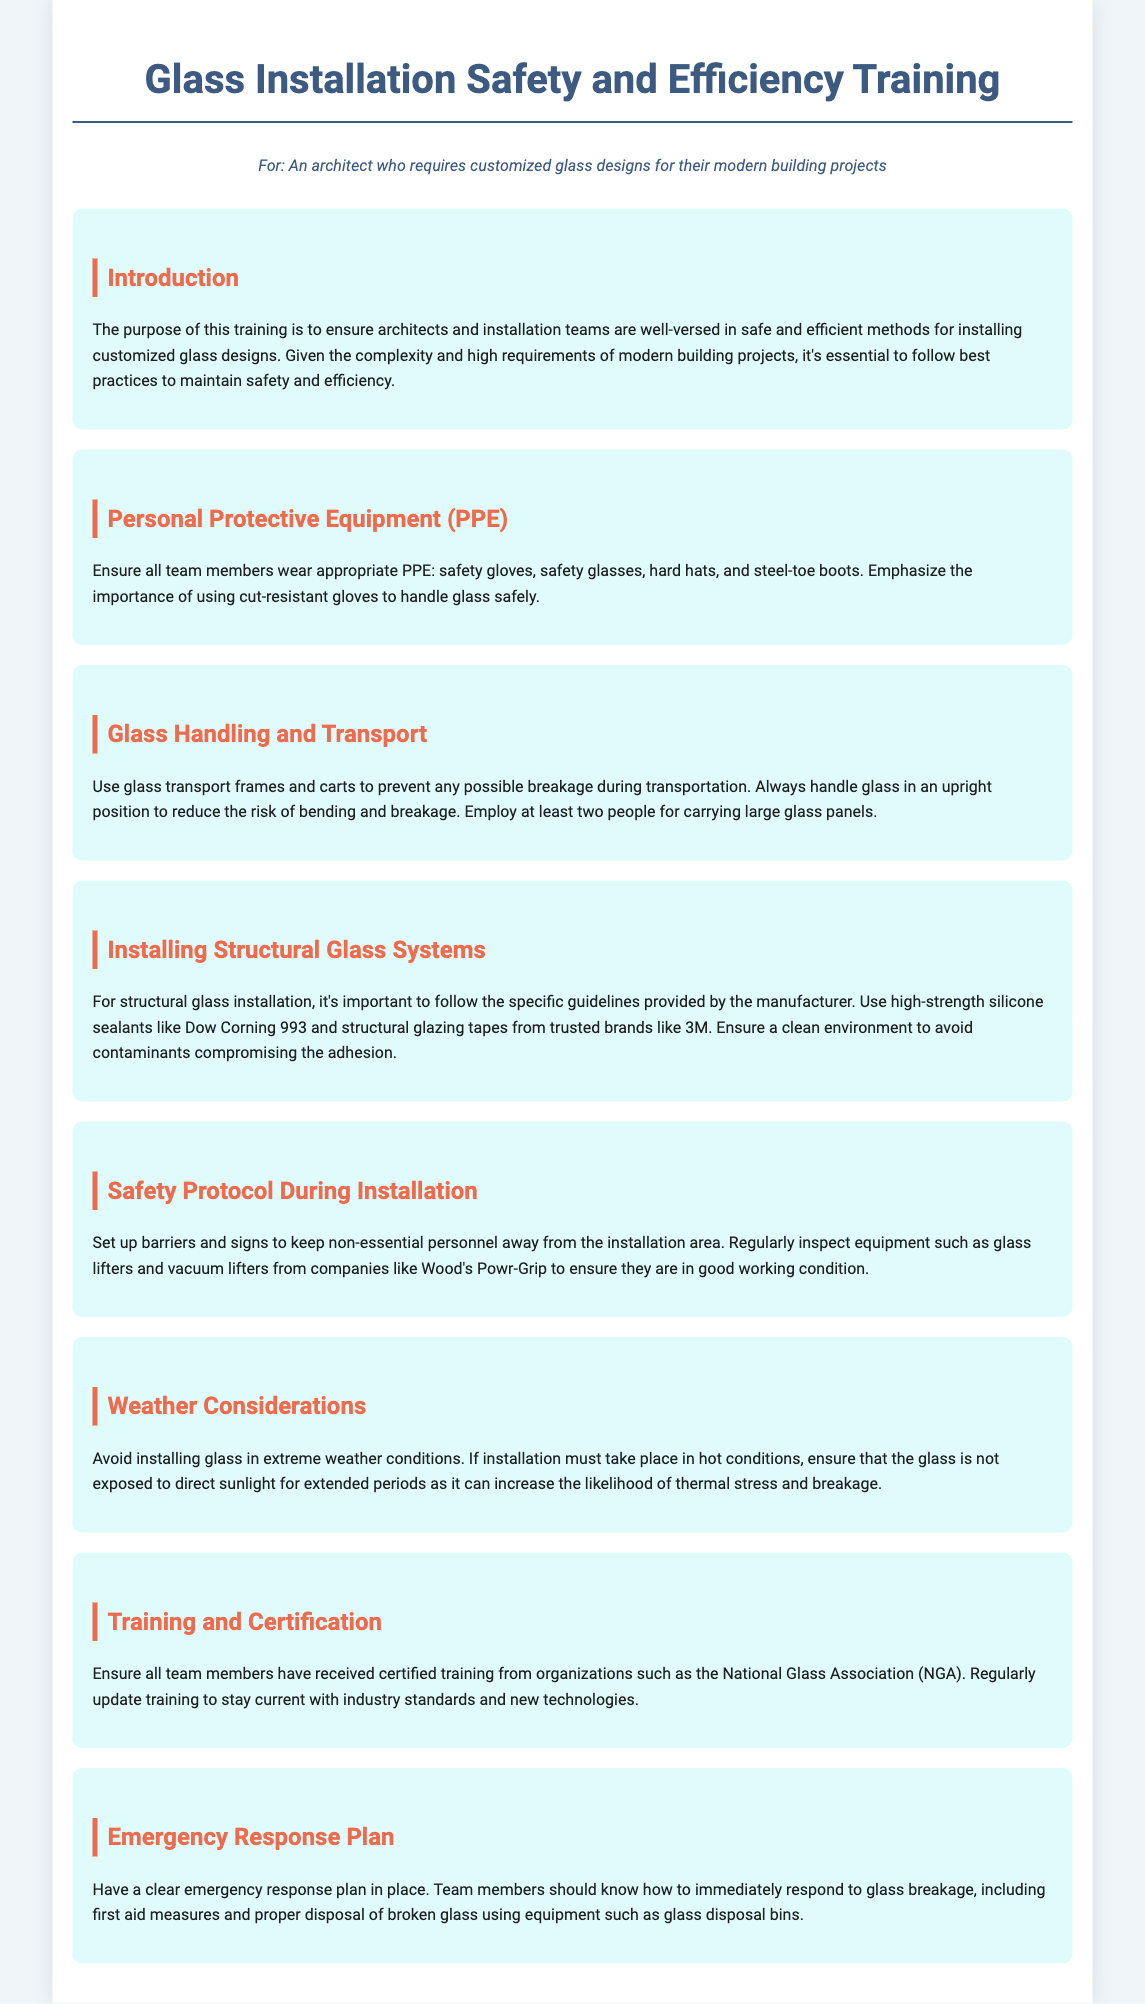What is the purpose of the training? The purpose of this training is to ensure architects and installation teams are well-versed in safe and efficient methods for installing customized glass designs.
Answer: To ensure safe and efficient methods for installing customized glass designs What type of sealants are recommended for structural glass installation? The document specifies using high-strength silicone sealants like Dow Corning 993 for structural glass installation.
Answer: Dow Corning 993 How should glass be transported to prevent breakage? The document advises using glass transport frames and carts to prevent any possible breakage during transportation.
Answer: Glass transport frames and carts How many people are recommended to carry large glass panels? The document suggests that at least two people are required for carrying large glass panels.
Answer: Two people What organization provides certified training for glass installation? The document mentions the National Glass Association (NGA) as the organization that provides certified training.
Answer: National Glass Association (NGA) Why should installation avoid extreme weather conditions? The document warns that extreme weather conditions can increase the likelihood of thermal stress and breakage during installation.
Answer: Thermal stress and breakage What should be used for proper disposal of broken glass? The document states that equipment such as glass disposal bins should be used for proper disposal of broken glass.
Answer: Glass disposal bins What is emphasized for the Personal Protective Equipment (PPE)? The document emphasizes the importance of using cut-resistant gloves to handle glass safely as part of the PPE.
Answer: Cut-resistant gloves 